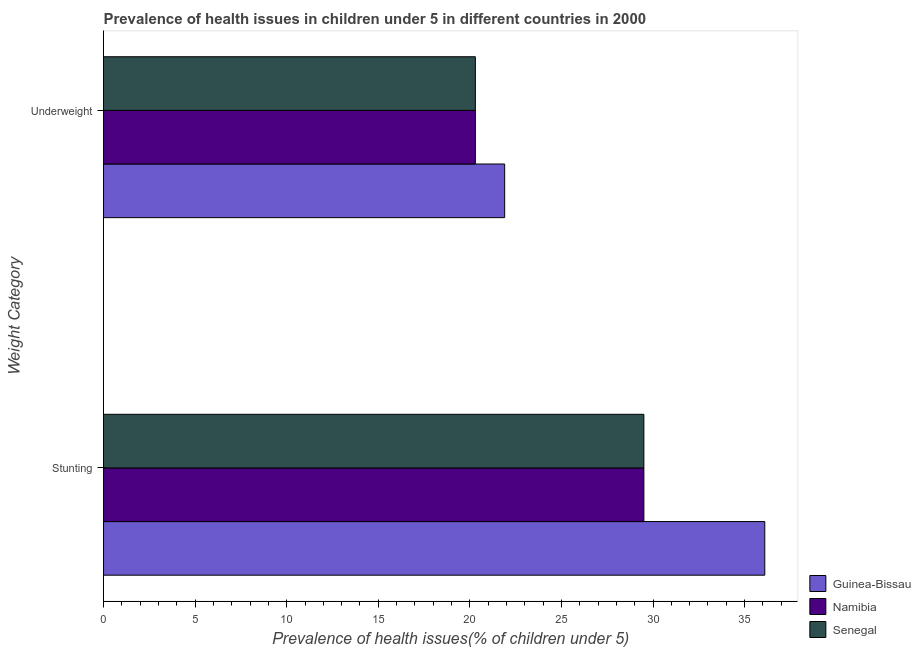How many different coloured bars are there?
Give a very brief answer. 3. Are the number of bars per tick equal to the number of legend labels?
Your response must be concise. Yes. Are the number of bars on each tick of the Y-axis equal?
Provide a short and direct response. Yes. What is the label of the 2nd group of bars from the top?
Ensure brevity in your answer.  Stunting. What is the percentage of stunted children in Guinea-Bissau?
Your answer should be compact. 36.1. Across all countries, what is the maximum percentage of stunted children?
Ensure brevity in your answer.  36.1. Across all countries, what is the minimum percentage of underweight children?
Provide a succinct answer. 20.3. In which country was the percentage of underweight children maximum?
Give a very brief answer. Guinea-Bissau. In which country was the percentage of underweight children minimum?
Your answer should be very brief. Namibia. What is the total percentage of stunted children in the graph?
Provide a succinct answer. 95.1. What is the difference between the percentage of stunted children in Namibia and that in Guinea-Bissau?
Offer a terse response. -6.6. What is the difference between the percentage of stunted children in Guinea-Bissau and the percentage of underweight children in Senegal?
Make the answer very short. 15.8. What is the average percentage of stunted children per country?
Your answer should be very brief. 31.7. What is the difference between the percentage of stunted children and percentage of underweight children in Guinea-Bissau?
Your answer should be very brief. 14.2. In how many countries, is the percentage of underweight children greater than 3 %?
Your response must be concise. 3. What is the ratio of the percentage of underweight children in Guinea-Bissau to that in Senegal?
Your response must be concise. 1.08. Is the percentage of stunted children in Guinea-Bissau less than that in Namibia?
Your answer should be very brief. No. In how many countries, is the percentage of underweight children greater than the average percentage of underweight children taken over all countries?
Offer a terse response. 1. What does the 3rd bar from the top in Stunting represents?
Offer a terse response. Guinea-Bissau. What does the 2nd bar from the bottom in Underweight represents?
Ensure brevity in your answer.  Namibia. How many bars are there?
Ensure brevity in your answer.  6. Are all the bars in the graph horizontal?
Your answer should be compact. Yes. How many countries are there in the graph?
Your response must be concise. 3. What is the difference between two consecutive major ticks on the X-axis?
Provide a short and direct response. 5. Are the values on the major ticks of X-axis written in scientific E-notation?
Your response must be concise. No. Where does the legend appear in the graph?
Make the answer very short. Bottom right. What is the title of the graph?
Your answer should be compact. Prevalence of health issues in children under 5 in different countries in 2000. Does "Bahrain" appear as one of the legend labels in the graph?
Make the answer very short. No. What is the label or title of the X-axis?
Ensure brevity in your answer.  Prevalence of health issues(% of children under 5). What is the label or title of the Y-axis?
Provide a short and direct response. Weight Category. What is the Prevalence of health issues(% of children under 5) in Guinea-Bissau in Stunting?
Your answer should be compact. 36.1. What is the Prevalence of health issues(% of children under 5) in Namibia in Stunting?
Offer a terse response. 29.5. What is the Prevalence of health issues(% of children under 5) of Senegal in Stunting?
Make the answer very short. 29.5. What is the Prevalence of health issues(% of children under 5) of Guinea-Bissau in Underweight?
Ensure brevity in your answer.  21.9. What is the Prevalence of health issues(% of children under 5) in Namibia in Underweight?
Your answer should be compact. 20.3. What is the Prevalence of health issues(% of children under 5) in Senegal in Underweight?
Make the answer very short. 20.3. Across all Weight Category, what is the maximum Prevalence of health issues(% of children under 5) in Guinea-Bissau?
Your answer should be very brief. 36.1. Across all Weight Category, what is the maximum Prevalence of health issues(% of children under 5) in Namibia?
Your answer should be very brief. 29.5. Across all Weight Category, what is the maximum Prevalence of health issues(% of children under 5) in Senegal?
Your answer should be very brief. 29.5. Across all Weight Category, what is the minimum Prevalence of health issues(% of children under 5) of Guinea-Bissau?
Offer a terse response. 21.9. Across all Weight Category, what is the minimum Prevalence of health issues(% of children under 5) of Namibia?
Provide a succinct answer. 20.3. Across all Weight Category, what is the minimum Prevalence of health issues(% of children under 5) in Senegal?
Provide a short and direct response. 20.3. What is the total Prevalence of health issues(% of children under 5) in Guinea-Bissau in the graph?
Your response must be concise. 58. What is the total Prevalence of health issues(% of children under 5) in Namibia in the graph?
Keep it short and to the point. 49.8. What is the total Prevalence of health issues(% of children under 5) in Senegal in the graph?
Make the answer very short. 49.8. What is the difference between the Prevalence of health issues(% of children under 5) of Senegal in Stunting and that in Underweight?
Give a very brief answer. 9.2. What is the average Prevalence of health issues(% of children under 5) in Namibia per Weight Category?
Your answer should be compact. 24.9. What is the average Prevalence of health issues(% of children under 5) of Senegal per Weight Category?
Your answer should be compact. 24.9. What is the difference between the Prevalence of health issues(% of children under 5) of Guinea-Bissau and Prevalence of health issues(% of children under 5) of Senegal in Stunting?
Make the answer very short. 6.6. What is the ratio of the Prevalence of health issues(% of children under 5) in Guinea-Bissau in Stunting to that in Underweight?
Ensure brevity in your answer.  1.65. What is the ratio of the Prevalence of health issues(% of children under 5) in Namibia in Stunting to that in Underweight?
Offer a very short reply. 1.45. What is the ratio of the Prevalence of health issues(% of children under 5) of Senegal in Stunting to that in Underweight?
Offer a very short reply. 1.45. What is the difference between the highest and the second highest Prevalence of health issues(% of children under 5) of Namibia?
Make the answer very short. 9.2. What is the difference between the highest and the lowest Prevalence of health issues(% of children under 5) of Senegal?
Make the answer very short. 9.2. 